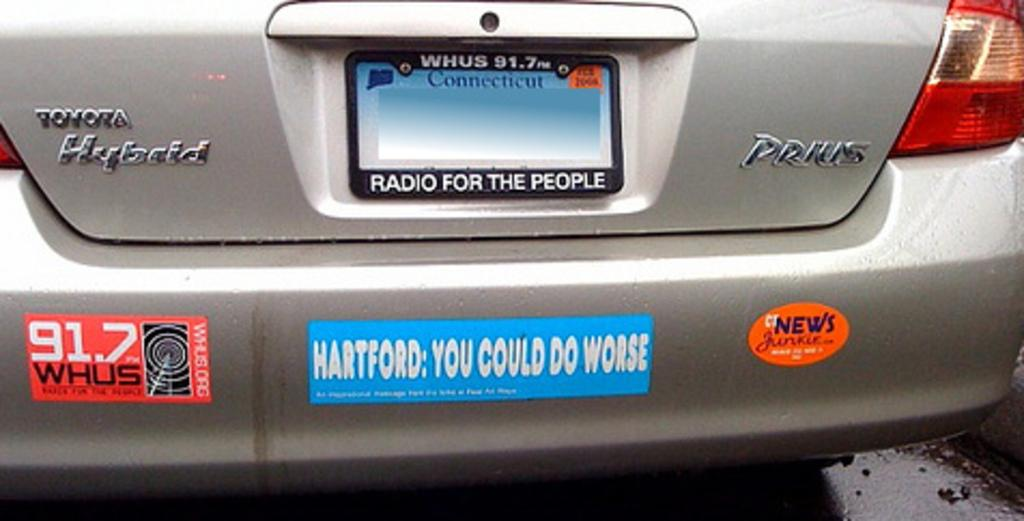<image>
Render a clear and concise summary of the photo. A Toyota Hybird has an empty Connecticut license plate 